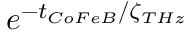Convert formula to latex. <formula><loc_0><loc_0><loc_500><loc_500>e ^ { - t _ { C o F e B } / \zeta _ { T H z } }</formula> 